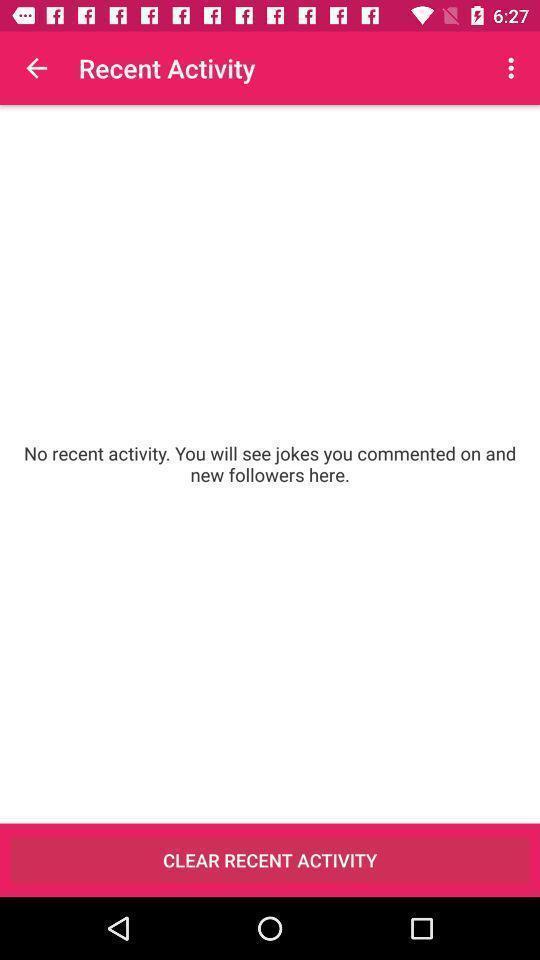Provide a detailed account of this screenshot. Page showing the recents activities. 